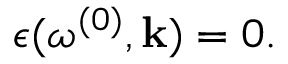Convert formula to latex. <formula><loc_0><loc_0><loc_500><loc_500>\epsilon ( \omega ^ { ( 0 ) } , { k } ) = 0 .</formula> 